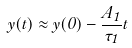<formula> <loc_0><loc_0><loc_500><loc_500>y ( t ) \approx y ( 0 ) - \frac { A _ { 1 } } { \tau _ { 1 } } t</formula> 